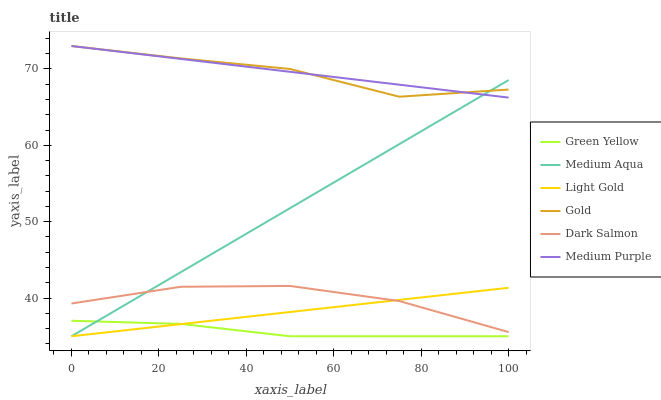Does Green Yellow have the minimum area under the curve?
Answer yes or no. Yes. Does Medium Purple have the maximum area under the curve?
Answer yes or no. Yes. Does Dark Salmon have the minimum area under the curve?
Answer yes or no. No. Does Dark Salmon have the maximum area under the curve?
Answer yes or no. No. Is Medium Purple the smoothest?
Answer yes or no. Yes. Is Gold the roughest?
Answer yes or no. Yes. Is Dark Salmon the smoothest?
Answer yes or no. No. Is Dark Salmon the roughest?
Answer yes or no. No. Does Medium Aqua have the lowest value?
Answer yes or no. Yes. Does Dark Salmon have the lowest value?
Answer yes or no. No. Does Medium Purple have the highest value?
Answer yes or no. Yes. Does Dark Salmon have the highest value?
Answer yes or no. No. Is Green Yellow less than Medium Purple?
Answer yes or no. Yes. Is Medium Purple greater than Dark Salmon?
Answer yes or no. Yes. Does Medium Aqua intersect Light Gold?
Answer yes or no. Yes. Is Medium Aqua less than Light Gold?
Answer yes or no. No. Is Medium Aqua greater than Light Gold?
Answer yes or no. No. Does Green Yellow intersect Medium Purple?
Answer yes or no. No. 